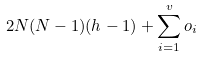Convert formula to latex. <formula><loc_0><loc_0><loc_500><loc_500>2 N ( N - 1 ) ( h - 1 ) + \sum _ { i = 1 } ^ { v } o _ { i }</formula> 